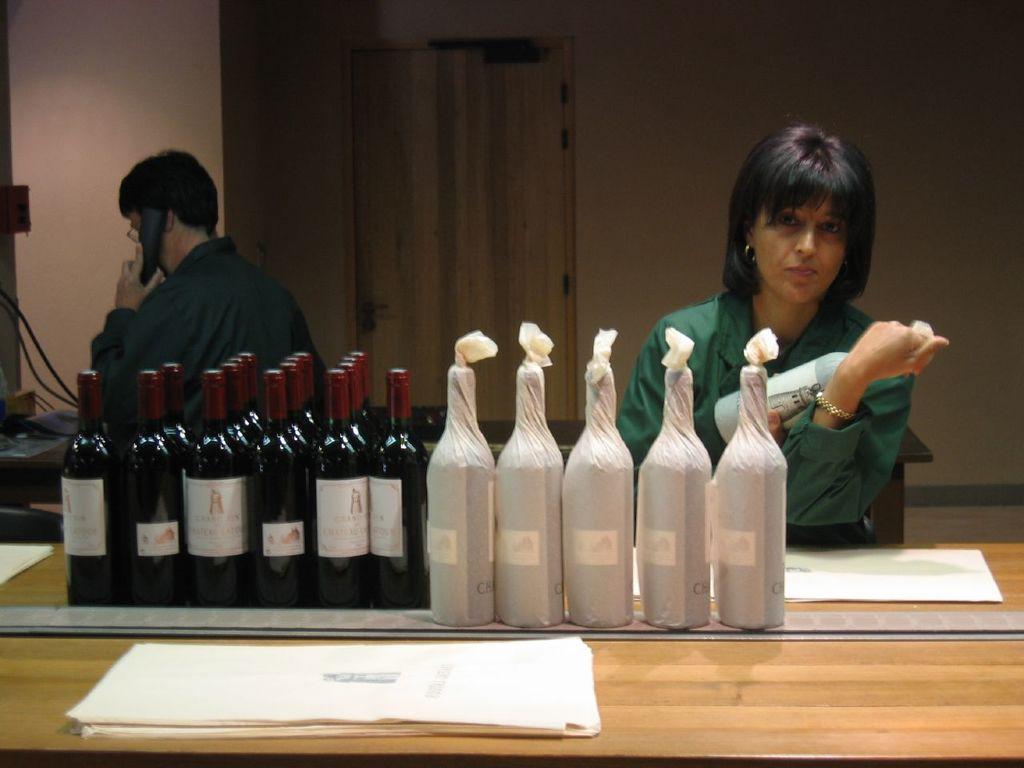In one or two sentences, can you explain what this image depicts? In this image we can see two persons. One person Is holding a phone in his hand. A woman is holding a bottle in her hand and standing in front of a table on which group of bottles, papers are placed. 